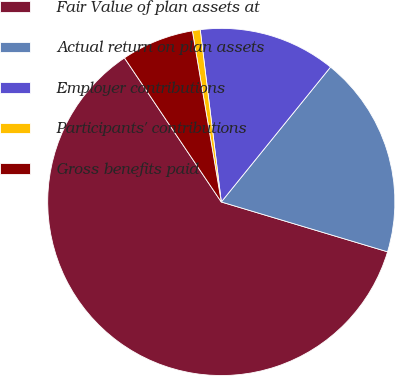Convert chart. <chart><loc_0><loc_0><loc_500><loc_500><pie_chart><fcel>Fair Value of plan assets at<fcel>Actual return on plan assets<fcel>Employer contributions<fcel>Participants' contributions<fcel>Gross benefits paid<nl><fcel>60.94%<fcel>18.8%<fcel>12.77%<fcel>0.73%<fcel>6.75%<nl></chart> 